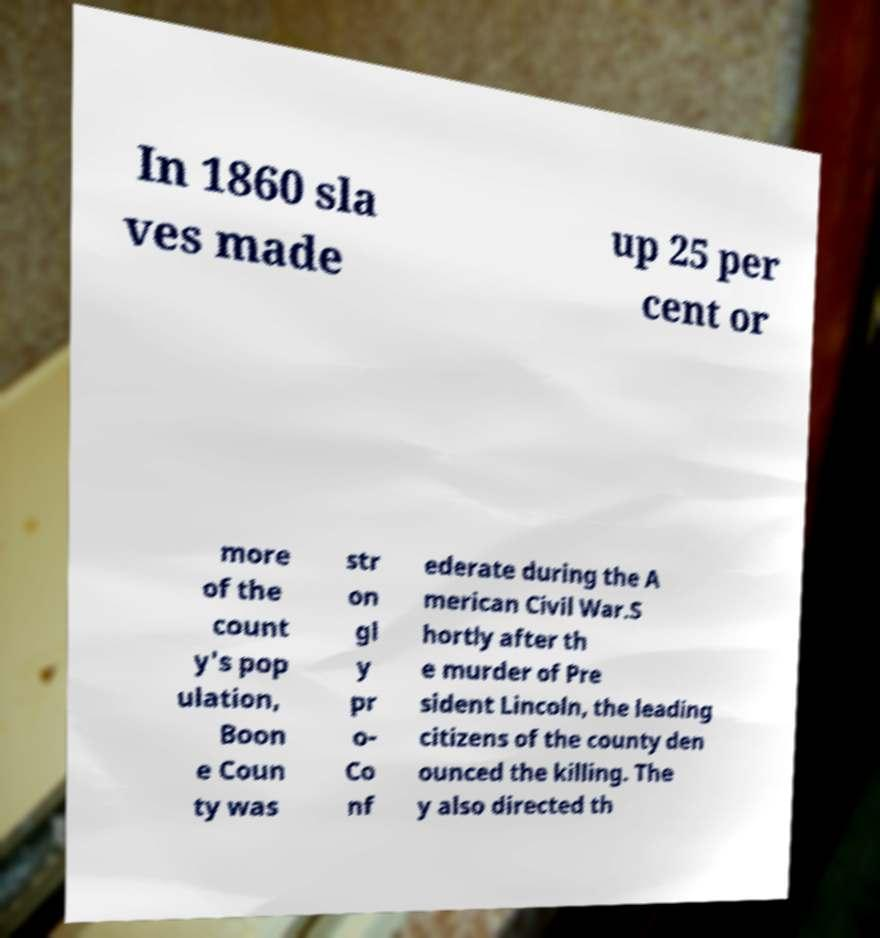There's text embedded in this image that I need extracted. Can you transcribe it verbatim? In 1860 sla ves made up 25 per cent or more of the count y's pop ulation, Boon e Coun ty was str on gl y pr o- Co nf ederate during the A merican Civil War.S hortly after th e murder of Pre sident Lincoln, the leading citizens of the county den ounced the killing. The y also directed th 